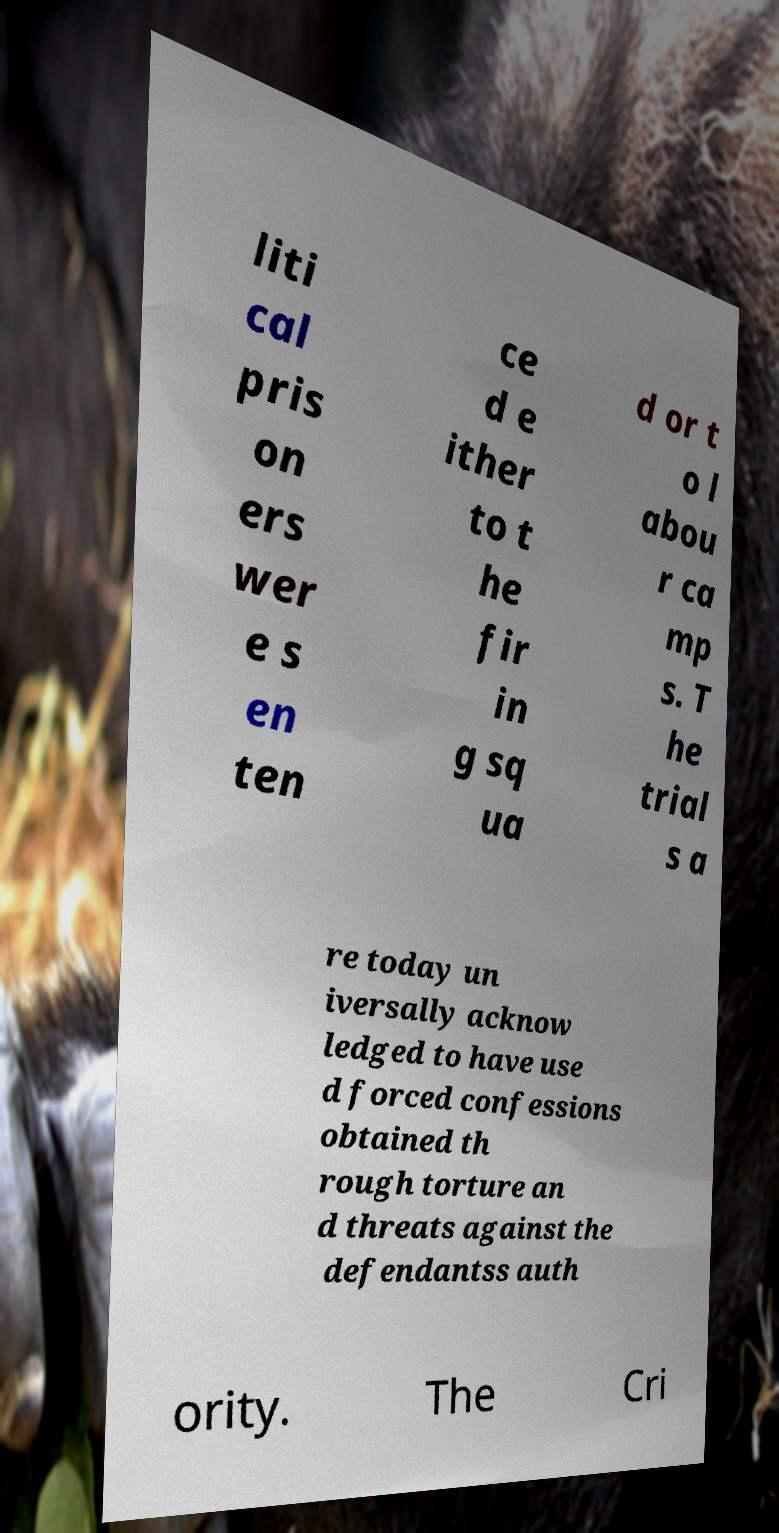For documentation purposes, I need the text within this image transcribed. Could you provide that? liti cal pris on ers wer e s en ten ce d e ither to t he fir in g sq ua d or t o l abou r ca mp s. T he trial s a re today un iversally acknow ledged to have use d forced confessions obtained th rough torture an d threats against the defendantss auth ority. The Cri 